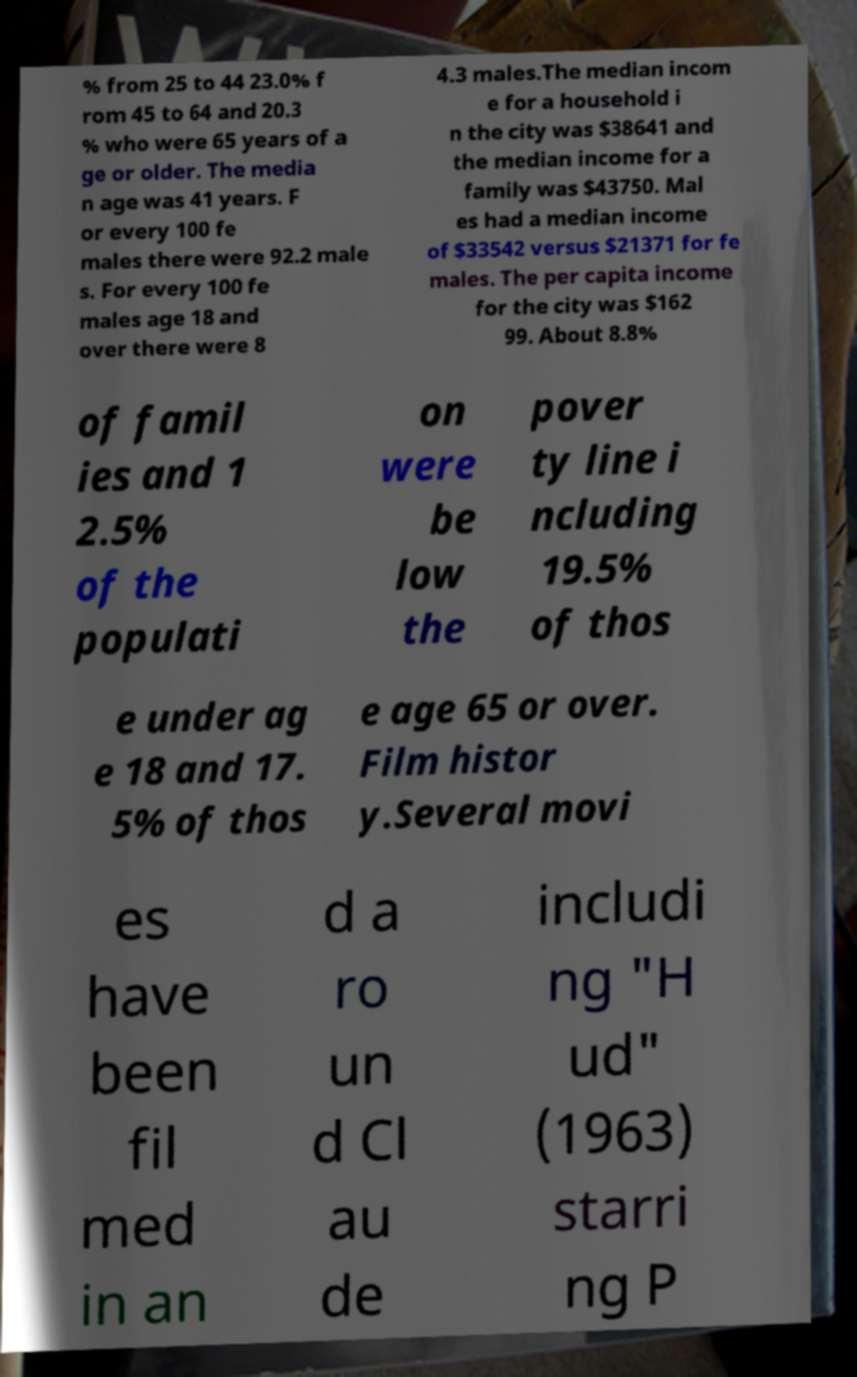I need the written content from this picture converted into text. Can you do that? % from 25 to 44 23.0% f rom 45 to 64 and 20.3 % who were 65 years of a ge or older. The media n age was 41 years. F or every 100 fe males there were 92.2 male s. For every 100 fe males age 18 and over there were 8 4.3 males.The median incom e for a household i n the city was $38641 and the median income for a family was $43750. Mal es had a median income of $33542 versus $21371 for fe males. The per capita income for the city was $162 99. About 8.8% of famil ies and 1 2.5% of the populati on were be low the pover ty line i ncluding 19.5% of thos e under ag e 18 and 17. 5% of thos e age 65 or over. Film histor y.Several movi es have been fil med in an d a ro un d Cl au de includi ng "H ud" (1963) starri ng P 